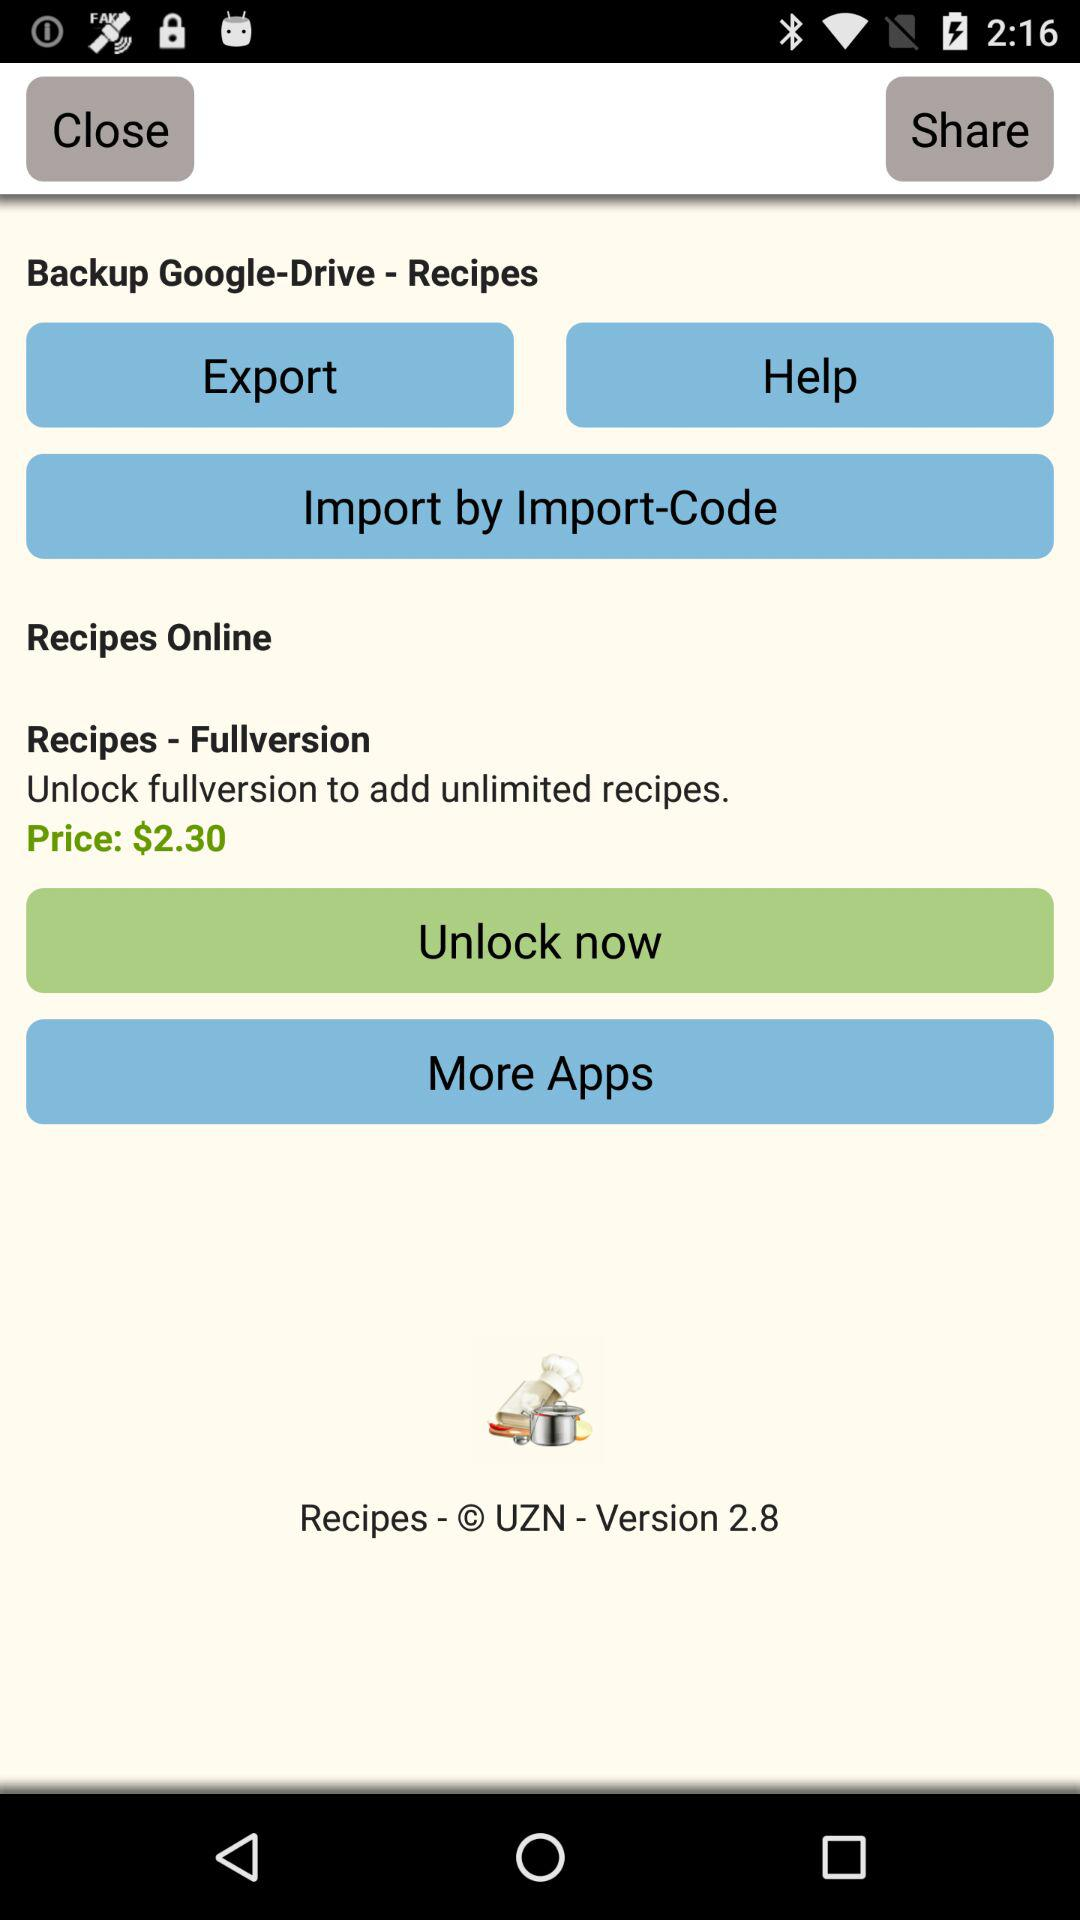What is the version of the application? The version is 2.8. 